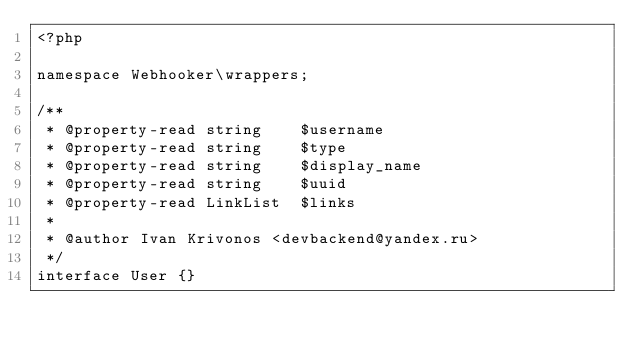Convert code to text. <code><loc_0><loc_0><loc_500><loc_500><_PHP_><?php

namespace Webhooker\wrappers;

/**
 * @property-read string    $username
 * @property-read string    $type
 * @property-read string    $display_name
 * @property-read string    $uuid
 * @property-read LinkList  $links
 *
 * @author Ivan Krivonos <devbackend@yandex.ru>
 */
interface User {}</code> 